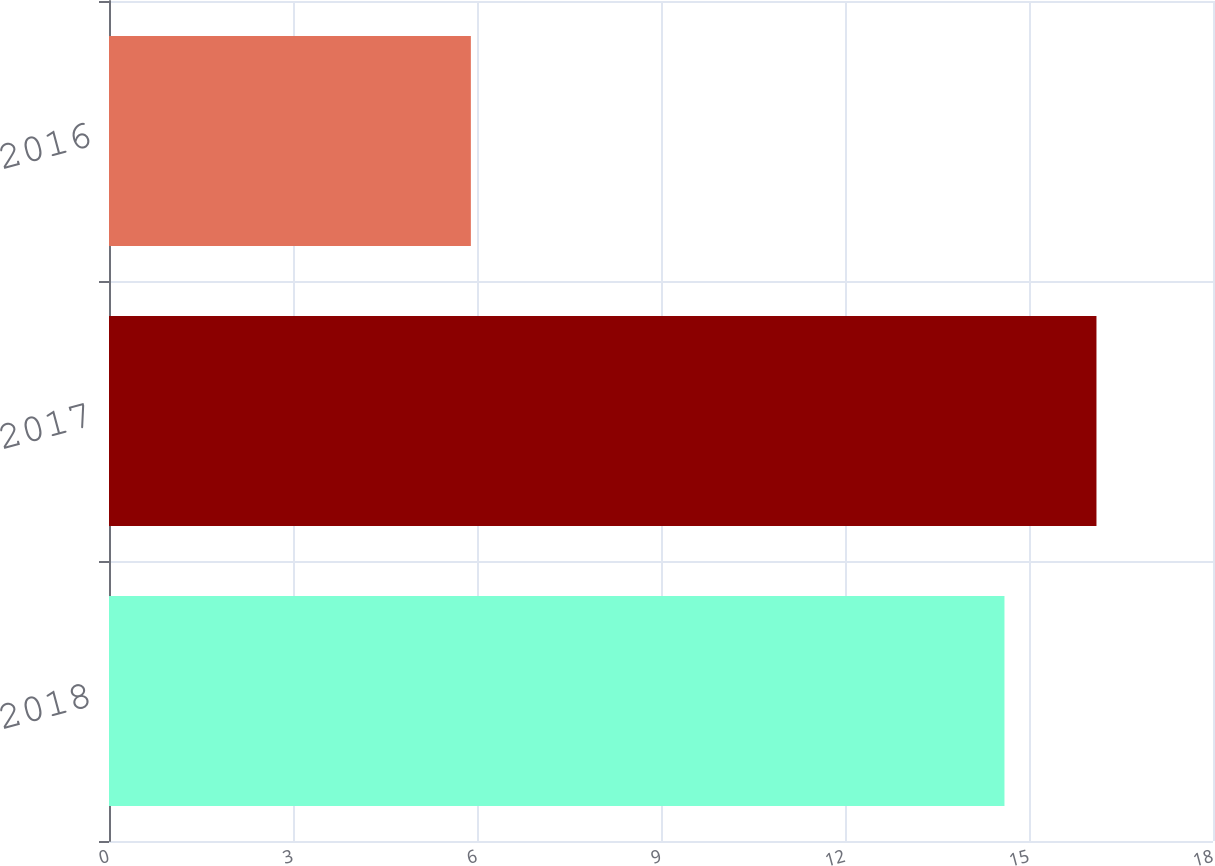Convert chart. <chart><loc_0><loc_0><loc_500><loc_500><bar_chart><fcel>2018<fcel>2017<fcel>2016<nl><fcel>14.6<fcel>16.1<fcel>5.9<nl></chart> 